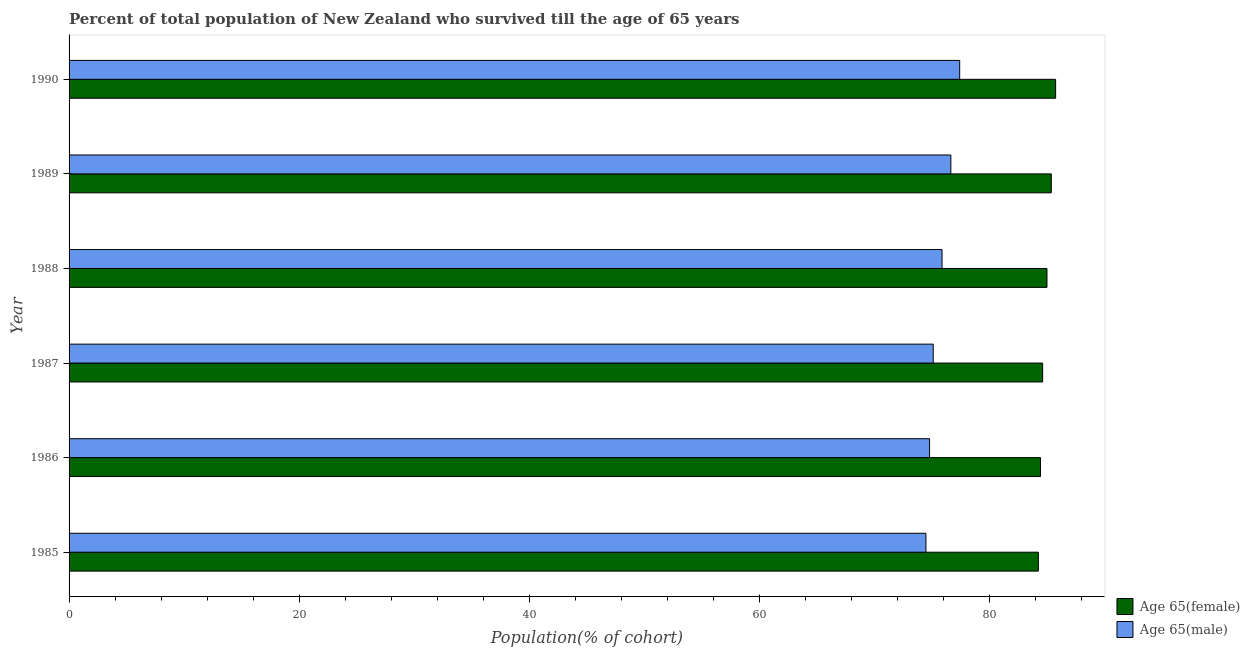How many different coloured bars are there?
Give a very brief answer. 2. How many groups of bars are there?
Keep it short and to the point. 6. Are the number of bars per tick equal to the number of legend labels?
Your response must be concise. Yes. Are the number of bars on each tick of the Y-axis equal?
Provide a short and direct response. Yes. In how many cases, is the number of bars for a given year not equal to the number of legend labels?
Ensure brevity in your answer.  0. What is the percentage of male population who survived till age of 65 in 1985?
Provide a succinct answer. 74.46. Across all years, what is the maximum percentage of female population who survived till age of 65?
Offer a terse response. 85.73. Across all years, what is the minimum percentage of female population who survived till age of 65?
Give a very brief answer. 84.23. In which year was the percentage of female population who survived till age of 65 maximum?
Provide a short and direct response. 1990. What is the total percentage of female population who survived till age of 65 in the graph?
Your answer should be compact. 509.29. What is the difference between the percentage of male population who survived till age of 65 in 1987 and that in 1988?
Your response must be concise. -0.77. What is the difference between the percentage of female population who survived till age of 65 in 1990 and the percentage of male population who survived till age of 65 in 1986?
Your answer should be very brief. 10.95. What is the average percentage of male population who survived till age of 65 per year?
Offer a very short reply. 75.7. In the year 1985, what is the difference between the percentage of female population who survived till age of 65 and percentage of male population who survived till age of 65?
Give a very brief answer. 9.77. In how many years, is the percentage of male population who survived till age of 65 greater than 68 %?
Offer a very short reply. 6. What is the ratio of the percentage of male population who survived till age of 65 in 1987 to that in 1990?
Ensure brevity in your answer.  0.97. Is the percentage of male population who survived till age of 65 in 1985 less than that in 1987?
Provide a short and direct response. Yes. Is the difference between the percentage of female population who survived till age of 65 in 1986 and 1990 greater than the difference between the percentage of male population who survived till age of 65 in 1986 and 1990?
Your response must be concise. Yes. What is the difference between the highest and the second highest percentage of female population who survived till age of 65?
Give a very brief answer. 0.38. What is the difference between the highest and the lowest percentage of male population who survived till age of 65?
Give a very brief answer. 2.93. In how many years, is the percentage of female population who survived till age of 65 greater than the average percentage of female population who survived till age of 65 taken over all years?
Keep it short and to the point. 3. Is the sum of the percentage of female population who survived till age of 65 in 1986 and 1989 greater than the maximum percentage of male population who survived till age of 65 across all years?
Your answer should be very brief. Yes. What does the 1st bar from the top in 1986 represents?
Offer a terse response. Age 65(male). What does the 2nd bar from the bottom in 1988 represents?
Make the answer very short. Age 65(male). Are all the bars in the graph horizontal?
Offer a terse response. Yes. What is the difference between two consecutive major ticks on the X-axis?
Your answer should be very brief. 20. Does the graph contain any zero values?
Provide a succinct answer. No. Where does the legend appear in the graph?
Give a very brief answer. Bottom right. How are the legend labels stacked?
Your answer should be very brief. Vertical. What is the title of the graph?
Make the answer very short. Percent of total population of New Zealand who survived till the age of 65 years. What is the label or title of the X-axis?
Your answer should be compact. Population(% of cohort). What is the label or title of the Y-axis?
Offer a terse response. Year. What is the Population(% of cohort) of Age 65(female) in 1985?
Give a very brief answer. 84.23. What is the Population(% of cohort) in Age 65(male) in 1985?
Provide a succinct answer. 74.46. What is the Population(% of cohort) in Age 65(female) in 1986?
Your response must be concise. 84.41. What is the Population(% of cohort) of Age 65(male) in 1986?
Offer a terse response. 74.77. What is the Population(% of cohort) of Age 65(female) in 1987?
Provide a succinct answer. 84.6. What is the Population(% of cohort) of Age 65(male) in 1987?
Provide a short and direct response. 75.09. What is the Population(% of cohort) in Age 65(female) in 1988?
Offer a terse response. 84.97. What is the Population(% of cohort) of Age 65(male) in 1988?
Your answer should be very brief. 75.86. What is the Population(% of cohort) in Age 65(female) in 1989?
Offer a terse response. 85.35. What is the Population(% of cohort) in Age 65(male) in 1989?
Keep it short and to the point. 76.62. What is the Population(% of cohort) in Age 65(female) in 1990?
Provide a short and direct response. 85.73. What is the Population(% of cohort) in Age 65(male) in 1990?
Provide a succinct answer. 77.39. Across all years, what is the maximum Population(% of cohort) in Age 65(female)?
Your answer should be very brief. 85.73. Across all years, what is the maximum Population(% of cohort) of Age 65(male)?
Ensure brevity in your answer.  77.39. Across all years, what is the minimum Population(% of cohort) of Age 65(female)?
Your answer should be compact. 84.23. Across all years, what is the minimum Population(% of cohort) of Age 65(male)?
Offer a very short reply. 74.46. What is the total Population(% of cohort) in Age 65(female) in the graph?
Your answer should be compact. 509.29. What is the total Population(% of cohort) of Age 65(male) in the graph?
Your answer should be very brief. 454.19. What is the difference between the Population(% of cohort) in Age 65(female) in 1985 and that in 1986?
Offer a terse response. -0.19. What is the difference between the Population(% of cohort) in Age 65(male) in 1985 and that in 1986?
Your response must be concise. -0.32. What is the difference between the Population(% of cohort) of Age 65(female) in 1985 and that in 1987?
Give a very brief answer. -0.37. What is the difference between the Population(% of cohort) in Age 65(male) in 1985 and that in 1987?
Offer a very short reply. -0.63. What is the difference between the Population(% of cohort) of Age 65(female) in 1985 and that in 1988?
Ensure brevity in your answer.  -0.75. What is the difference between the Population(% of cohort) of Age 65(male) in 1985 and that in 1988?
Give a very brief answer. -1.4. What is the difference between the Population(% of cohort) in Age 65(female) in 1985 and that in 1989?
Your response must be concise. -1.12. What is the difference between the Population(% of cohort) in Age 65(male) in 1985 and that in 1989?
Offer a very short reply. -2.17. What is the difference between the Population(% of cohort) of Age 65(female) in 1985 and that in 1990?
Provide a succinct answer. -1.5. What is the difference between the Population(% of cohort) of Age 65(male) in 1985 and that in 1990?
Make the answer very short. -2.93. What is the difference between the Population(% of cohort) in Age 65(female) in 1986 and that in 1987?
Provide a succinct answer. -0.19. What is the difference between the Population(% of cohort) in Age 65(male) in 1986 and that in 1987?
Give a very brief answer. -0.32. What is the difference between the Population(% of cohort) of Age 65(female) in 1986 and that in 1988?
Your response must be concise. -0.56. What is the difference between the Population(% of cohort) of Age 65(male) in 1986 and that in 1988?
Offer a very short reply. -1.08. What is the difference between the Population(% of cohort) in Age 65(female) in 1986 and that in 1989?
Make the answer very short. -0.94. What is the difference between the Population(% of cohort) of Age 65(male) in 1986 and that in 1989?
Offer a very short reply. -1.85. What is the difference between the Population(% of cohort) of Age 65(female) in 1986 and that in 1990?
Provide a short and direct response. -1.31. What is the difference between the Population(% of cohort) of Age 65(male) in 1986 and that in 1990?
Make the answer very short. -2.62. What is the difference between the Population(% of cohort) of Age 65(female) in 1987 and that in 1988?
Your answer should be compact. -0.38. What is the difference between the Population(% of cohort) of Age 65(male) in 1987 and that in 1988?
Provide a short and direct response. -0.77. What is the difference between the Population(% of cohort) in Age 65(female) in 1987 and that in 1989?
Give a very brief answer. -0.75. What is the difference between the Population(% of cohort) in Age 65(male) in 1987 and that in 1989?
Provide a succinct answer. -1.53. What is the difference between the Population(% of cohort) of Age 65(female) in 1987 and that in 1990?
Your response must be concise. -1.13. What is the difference between the Population(% of cohort) in Age 65(male) in 1987 and that in 1990?
Offer a terse response. -2.3. What is the difference between the Population(% of cohort) in Age 65(female) in 1988 and that in 1989?
Provide a short and direct response. -0.38. What is the difference between the Population(% of cohort) in Age 65(male) in 1988 and that in 1989?
Offer a terse response. -0.77. What is the difference between the Population(% of cohort) in Age 65(female) in 1988 and that in 1990?
Offer a terse response. -0.75. What is the difference between the Population(% of cohort) of Age 65(male) in 1988 and that in 1990?
Give a very brief answer. -1.53. What is the difference between the Population(% of cohort) of Age 65(female) in 1989 and that in 1990?
Your response must be concise. -0.38. What is the difference between the Population(% of cohort) of Age 65(male) in 1989 and that in 1990?
Your response must be concise. -0.77. What is the difference between the Population(% of cohort) of Age 65(female) in 1985 and the Population(% of cohort) of Age 65(male) in 1986?
Your answer should be compact. 9.45. What is the difference between the Population(% of cohort) in Age 65(female) in 1985 and the Population(% of cohort) in Age 65(male) in 1987?
Give a very brief answer. 9.14. What is the difference between the Population(% of cohort) in Age 65(female) in 1985 and the Population(% of cohort) in Age 65(male) in 1988?
Provide a short and direct response. 8.37. What is the difference between the Population(% of cohort) in Age 65(female) in 1985 and the Population(% of cohort) in Age 65(male) in 1989?
Ensure brevity in your answer.  7.6. What is the difference between the Population(% of cohort) in Age 65(female) in 1985 and the Population(% of cohort) in Age 65(male) in 1990?
Your answer should be compact. 6.84. What is the difference between the Population(% of cohort) of Age 65(female) in 1986 and the Population(% of cohort) of Age 65(male) in 1987?
Provide a succinct answer. 9.32. What is the difference between the Population(% of cohort) of Age 65(female) in 1986 and the Population(% of cohort) of Age 65(male) in 1988?
Make the answer very short. 8.56. What is the difference between the Population(% of cohort) in Age 65(female) in 1986 and the Population(% of cohort) in Age 65(male) in 1989?
Offer a terse response. 7.79. What is the difference between the Population(% of cohort) of Age 65(female) in 1986 and the Population(% of cohort) of Age 65(male) in 1990?
Your answer should be compact. 7.02. What is the difference between the Population(% of cohort) in Age 65(female) in 1987 and the Population(% of cohort) in Age 65(male) in 1988?
Give a very brief answer. 8.74. What is the difference between the Population(% of cohort) in Age 65(female) in 1987 and the Population(% of cohort) in Age 65(male) in 1989?
Make the answer very short. 7.97. What is the difference between the Population(% of cohort) of Age 65(female) in 1987 and the Population(% of cohort) of Age 65(male) in 1990?
Provide a succinct answer. 7.21. What is the difference between the Population(% of cohort) in Age 65(female) in 1988 and the Population(% of cohort) in Age 65(male) in 1989?
Your answer should be compact. 8.35. What is the difference between the Population(% of cohort) of Age 65(female) in 1988 and the Population(% of cohort) of Age 65(male) in 1990?
Ensure brevity in your answer.  7.58. What is the difference between the Population(% of cohort) of Age 65(female) in 1989 and the Population(% of cohort) of Age 65(male) in 1990?
Keep it short and to the point. 7.96. What is the average Population(% of cohort) of Age 65(female) per year?
Offer a very short reply. 84.88. What is the average Population(% of cohort) of Age 65(male) per year?
Offer a very short reply. 75.7. In the year 1985, what is the difference between the Population(% of cohort) of Age 65(female) and Population(% of cohort) of Age 65(male)?
Offer a very short reply. 9.77. In the year 1986, what is the difference between the Population(% of cohort) in Age 65(female) and Population(% of cohort) in Age 65(male)?
Make the answer very short. 9.64. In the year 1987, what is the difference between the Population(% of cohort) of Age 65(female) and Population(% of cohort) of Age 65(male)?
Provide a short and direct response. 9.51. In the year 1988, what is the difference between the Population(% of cohort) of Age 65(female) and Population(% of cohort) of Age 65(male)?
Make the answer very short. 9.12. In the year 1989, what is the difference between the Population(% of cohort) of Age 65(female) and Population(% of cohort) of Age 65(male)?
Ensure brevity in your answer.  8.73. In the year 1990, what is the difference between the Population(% of cohort) of Age 65(female) and Population(% of cohort) of Age 65(male)?
Keep it short and to the point. 8.34. What is the ratio of the Population(% of cohort) in Age 65(male) in 1985 to that in 1986?
Make the answer very short. 1. What is the ratio of the Population(% of cohort) in Age 65(female) in 1985 to that in 1987?
Ensure brevity in your answer.  1. What is the ratio of the Population(% of cohort) of Age 65(female) in 1985 to that in 1988?
Your answer should be compact. 0.99. What is the ratio of the Population(% of cohort) of Age 65(male) in 1985 to that in 1988?
Provide a succinct answer. 0.98. What is the ratio of the Population(% of cohort) in Age 65(female) in 1985 to that in 1989?
Your answer should be very brief. 0.99. What is the ratio of the Population(% of cohort) of Age 65(male) in 1985 to that in 1989?
Your response must be concise. 0.97. What is the ratio of the Population(% of cohort) of Age 65(female) in 1985 to that in 1990?
Your answer should be very brief. 0.98. What is the ratio of the Population(% of cohort) of Age 65(male) in 1985 to that in 1990?
Your response must be concise. 0.96. What is the ratio of the Population(% of cohort) of Age 65(male) in 1986 to that in 1987?
Keep it short and to the point. 1. What is the ratio of the Population(% of cohort) in Age 65(male) in 1986 to that in 1988?
Provide a succinct answer. 0.99. What is the ratio of the Population(% of cohort) of Age 65(female) in 1986 to that in 1989?
Keep it short and to the point. 0.99. What is the ratio of the Population(% of cohort) of Age 65(male) in 1986 to that in 1989?
Your response must be concise. 0.98. What is the ratio of the Population(% of cohort) of Age 65(female) in 1986 to that in 1990?
Make the answer very short. 0.98. What is the ratio of the Population(% of cohort) in Age 65(male) in 1986 to that in 1990?
Keep it short and to the point. 0.97. What is the ratio of the Population(% of cohort) in Age 65(female) in 1987 to that in 1988?
Provide a succinct answer. 1. What is the ratio of the Population(% of cohort) of Age 65(male) in 1987 to that in 1988?
Give a very brief answer. 0.99. What is the ratio of the Population(% of cohort) in Age 65(male) in 1987 to that in 1989?
Keep it short and to the point. 0.98. What is the ratio of the Population(% of cohort) in Age 65(female) in 1987 to that in 1990?
Ensure brevity in your answer.  0.99. What is the ratio of the Population(% of cohort) of Age 65(male) in 1987 to that in 1990?
Provide a short and direct response. 0.97. What is the ratio of the Population(% of cohort) in Age 65(female) in 1988 to that in 1989?
Make the answer very short. 1. What is the ratio of the Population(% of cohort) in Age 65(male) in 1988 to that in 1989?
Offer a very short reply. 0.99. What is the ratio of the Population(% of cohort) of Age 65(female) in 1988 to that in 1990?
Ensure brevity in your answer.  0.99. What is the ratio of the Population(% of cohort) in Age 65(male) in 1988 to that in 1990?
Ensure brevity in your answer.  0.98. What is the difference between the highest and the second highest Population(% of cohort) of Age 65(female)?
Offer a terse response. 0.38. What is the difference between the highest and the second highest Population(% of cohort) of Age 65(male)?
Give a very brief answer. 0.77. What is the difference between the highest and the lowest Population(% of cohort) of Age 65(female)?
Keep it short and to the point. 1.5. What is the difference between the highest and the lowest Population(% of cohort) in Age 65(male)?
Your response must be concise. 2.93. 